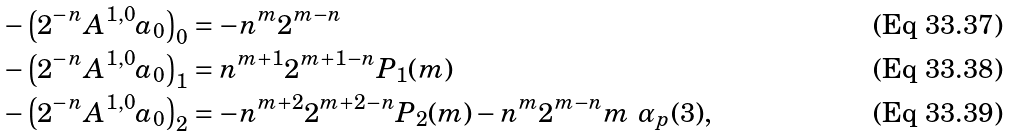<formula> <loc_0><loc_0><loc_500><loc_500>- \left ( 2 ^ { - n } A ^ { 1 , 0 } a _ { 0 } \right ) _ { 0 } & = - n ^ { m } 2 ^ { m - n } \\ - \left ( 2 ^ { - n } A ^ { 1 , 0 } a _ { 0 } \right ) _ { 1 } & = n ^ { m + 1 } 2 ^ { m + 1 - n } P _ { 1 } ( m ) \\ - \left ( 2 ^ { - n } A ^ { 1 , 0 } a _ { 0 } \right ) _ { 2 } & = - n ^ { m + 2 } 2 ^ { m + 2 - n } P _ { 2 } ( m ) - n ^ { m } 2 ^ { m - n } m \ \alpha _ { p } ( 3 ) ,</formula> 